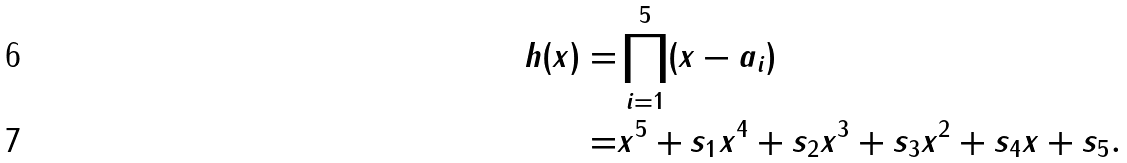Convert formula to latex. <formula><loc_0><loc_0><loc_500><loc_500>h ( x ) = & \prod _ { i = 1 } ^ { 5 } ( x - a _ { i } ) \\ = & x ^ { 5 } + s _ { 1 } x ^ { 4 } + s _ { 2 } x ^ { 3 } + s _ { 3 } x ^ { 2 } + s _ { 4 } x + s _ { 5 } .</formula> 